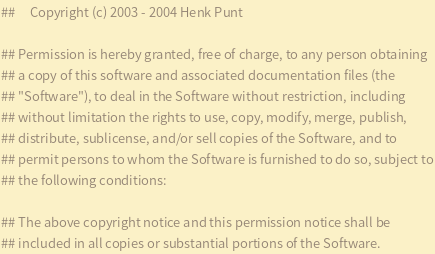<code> <loc_0><loc_0><loc_500><loc_500><_Python_>## 	   Copyright (c) 2003 - 2004 Henk Punt

## Permission is hereby granted, free of charge, to any person obtaining
## a copy of this software and associated documentation files (the
## "Software"), to deal in the Software without restriction, including
## without limitation the rights to use, copy, modify, merge, publish,
## distribute, sublicense, and/or sell copies of the Software, and to
## permit persons to whom the Software is furnished to do so, subject to
## the following conditions:

## The above copyright notice and this permission notice shall be
## included in all copies or substantial portions of the Software.
</code> 